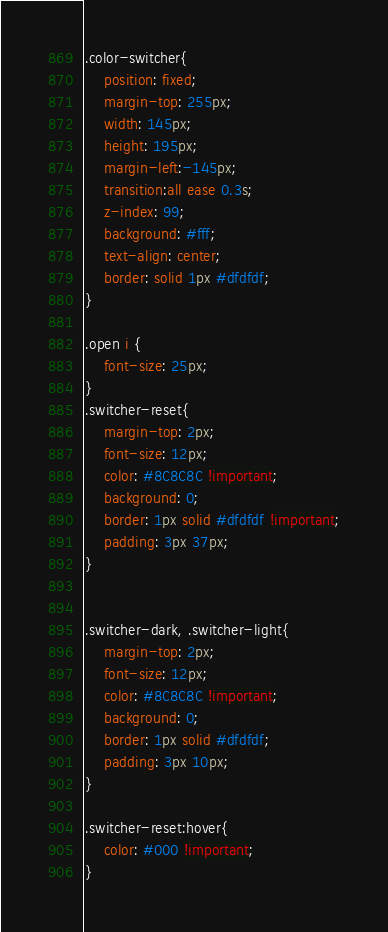Convert code to text. <code><loc_0><loc_0><loc_500><loc_500><_CSS_>
.color-switcher{
    position: fixed;
    margin-top: 255px;
    width: 145px;
    height: 195px;
    margin-left:-145px;
    transition:all ease 0.3s;
    z-index: 99;
    background: #fff;
    text-align: center;
    border: solid 1px #dfdfdf;
}

.open i {
    font-size: 25px;
}
.switcher-reset{
    margin-top: 2px;
    font-size: 12px;
    color: #8C8C8C !important;
    background: 0;
    border: 1px solid #dfdfdf !important;
    padding: 3px 37px;
}


.switcher-dark, .switcher-light{
    margin-top: 2px;
    font-size: 12px;
    color: #8C8C8C !important;
    background: 0;
    border: 1px solid #dfdfdf;
    padding: 3px 10px;
}

.switcher-reset:hover{
    color: #000 !important;
}
</code> 